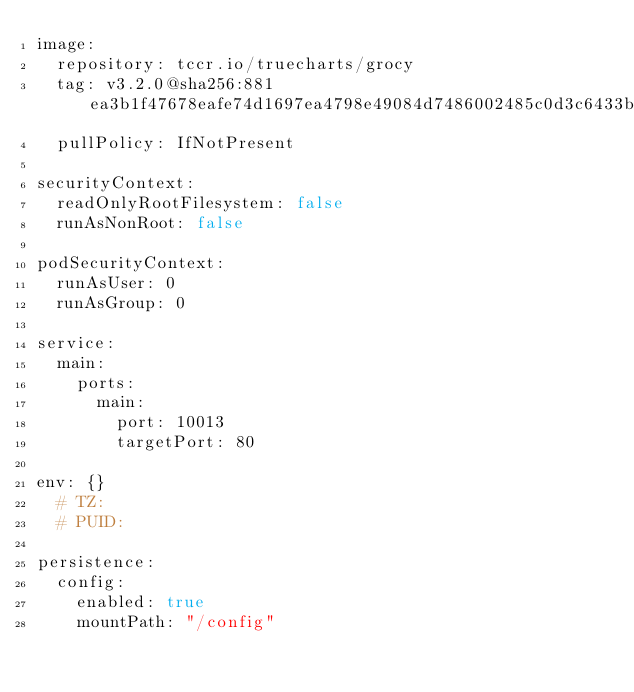Convert code to text. <code><loc_0><loc_0><loc_500><loc_500><_YAML_>image:
  repository: tccr.io/truecharts/grocy
  tag: v3.2.0@sha256:881ea3b1f47678eafe74d1697ea4798e49084d7486002485c0d3c6433b4b1710
  pullPolicy: IfNotPresent

securityContext:
  readOnlyRootFilesystem: false
  runAsNonRoot: false

podSecurityContext:
  runAsUser: 0
  runAsGroup: 0

service:
  main:
    ports:
      main:
        port: 10013
        targetPort: 80

env: {}
  # TZ:
  # PUID:

persistence:
  config:
    enabled: true
    mountPath: "/config"
</code> 